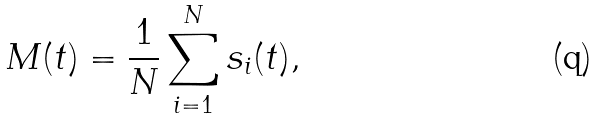<formula> <loc_0><loc_0><loc_500><loc_500>M ( t ) = \frac { 1 } { N } \sum _ { i = 1 } ^ { N } s _ { i } ( t ) ,</formula> 